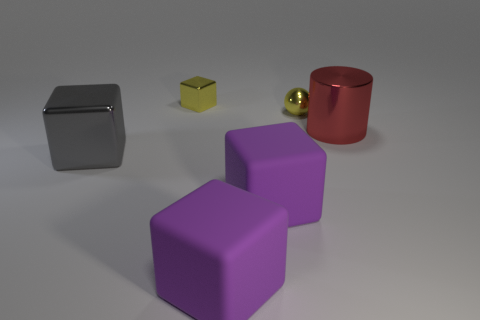How many other things are the same size as the yellow metal sphere?
Offer a terse response. 1. The yellow metal block is what size?
Make the answer very short. Small. There is a tiny shiny object that is the same shape as the big gray thing; what color is it?
Your answer should be compact. Yellow. There is a block that is behind the large red shiny cylinder; is its color the same as the shiny sphere?
Your answer should be compact. Yes. Are there any yellow shiny objects behind the yellow ball?
Keep it short and to the point. Yes. What is the color of the metal thing that is both right of the yellow metal cube and left of the big red cylinder?
Ensure brevity in your answer.  Yellow. There is a object that is the same color as the tiny sphere; what is its shape?
Offer a very short reply. Cube. What is the size of the yellow thing in front of the metal block that is on the right side of the gray metal object?
Make the answer very short. Small. How many cylinders are either gray things or tiny yellow things?
Offer a very short reply. 0. What is the color of the shiny cube that is the same size as the yellow ball?
Ensure brevity in your answer.  Yellow. 